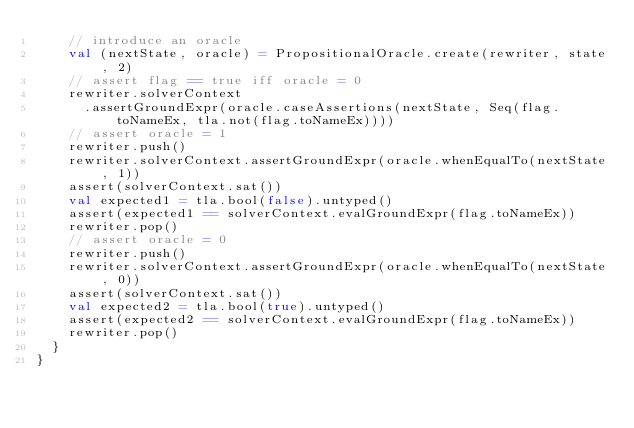<code> <loc_0><loc_0><loc_500><loc_500><_Scala_>    // introduce an oracle
    val (nextState, oracle) = PropositionalOracle.create(rewriter, state, 2)
    // assert flag == true iff oracle = 0
    rewriter.solverContext
      .assertGroundExpr(oracle.caseAssertions(nextState, Seq(flag.toNameEx, tla.not(flag.toNameEx))))
    // assert oracle = 1
    rewriter.push()
    rewriter.solverContext.assertGroundExpr(oracle.whenEqualTo(nextState, 1))
    assert(solverContext.sat())
    val expected1 = tla.bool(false).untyped()
    assert(expected1 == solverContext.evalGroundExpr(flag.toNameEx))
    rewriter.pop()
    // assert oracle = 0
    rewriter.push()
    rewriter.solverContext.assertGroundExpr(oracle.whenEqualTo(nextState, 0))
    assert(solverContext.sat())
    val expected2 = tla.bool(true).untyped()
    assert(expected2 == solverContext.evalGroundExpr(flag.toNameEx))
    rewriter.pop()
  }
}
</code> 